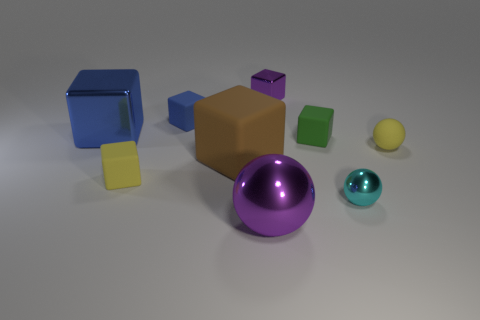What number of small cyan objects are the same shape as the big purple object?
Your answer should be compact. 1. There is a small yellow thing that is the same shape as the big blue metallic object; what material is it?
Provide a short and direct response. Rubber. There is a big shiny thing on the right side of the yellow matte object to the left of the purple thing that is on the right side of the large shiny sphere; what is its shape?
Provide a short and direct response. Sphere. There is a block that is in front of the blue metal object and to the left of the small blue block; what material is it made of?
Make the answer very short. Rubber. There is a small yellow thing behind the yellow thing to the left of the tiny green block; what is its shape?
Keep it short and to the point. Sphere. Are there any other things of the same color as the tiny shiny block?
Keep it short and to the point. Yes. There is a brown object; is its size the same as the sphere behind the big matte block?
Keep it short and to the point. No. What number of tiny objects are purple spheres or gray balls?
Make the answer very short. 0. Are there more small yellow cubes than blue cubes?
Provide a short and direct response. No. How many small cyan metallic balls are on the right side of the blue object that is in front of the tiny matte block that is behind the big blue block?
Make the answer very short. 1. 